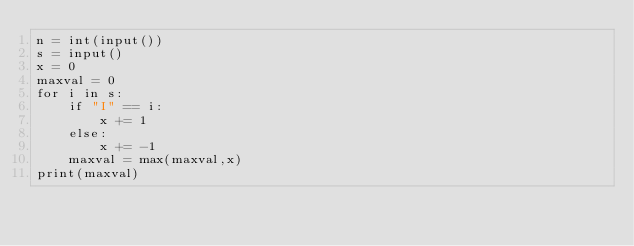Convert code to text. <code><loc_0><loc_0><loc_500><loc_500><_Python_>n = int(input())
s = input()
x = 0
maxval = 0
for i in s:
    if "I" == i:
        x += 1
    else:
        x += -1
    maxval = max(maxval,x)
print(maxval)</code> 